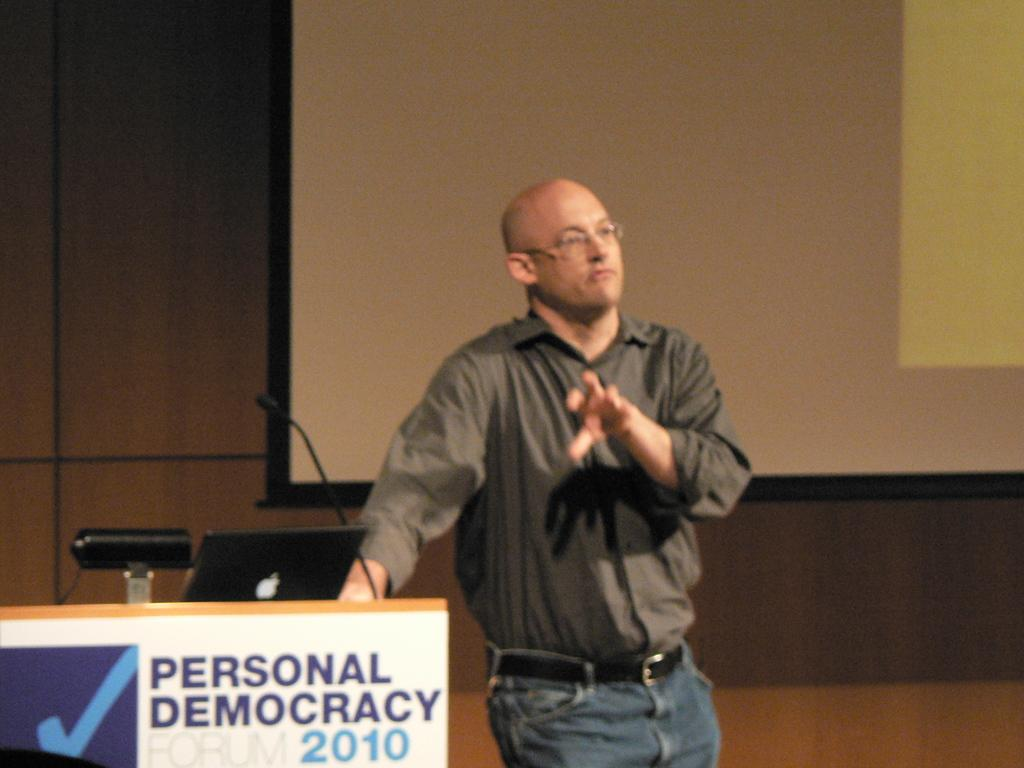Who is present in the image? There is a man in the image. What is the man doing in the image? The man is standing beside a table. What objects are on the table in the image? There is a laptop, a microphone, and other objects on the table. What is behind the man in the image? There is a projector screen behind the man. How many ladybugs can be seen on the laptop in the image? There are no ladybugs present on the laptop or anywhere else in the image. What type of bird is perched on the microphone in the image? There are no birds present in the image, including wrens or any other type of bird. 